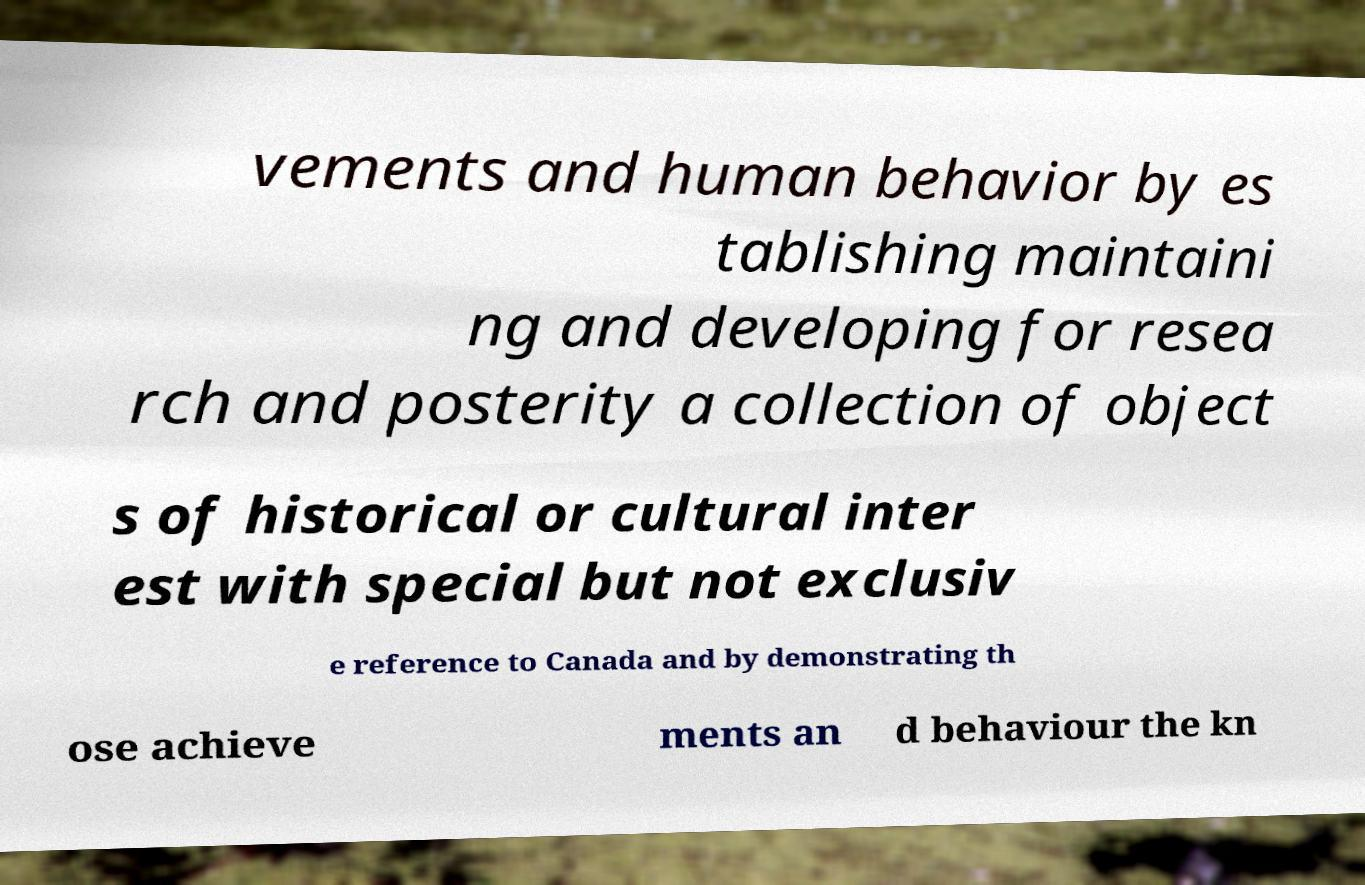I need the written content from this picture converted into text. Can you do that? vements and human behavior by es tablishing maintaini ng and developing for resea rch and posterity a collection of object s of historical or cultural inter est with special but not exclusiv e reference to Canada and by demonstrating th ose achieve ments an d behaviour the kn 